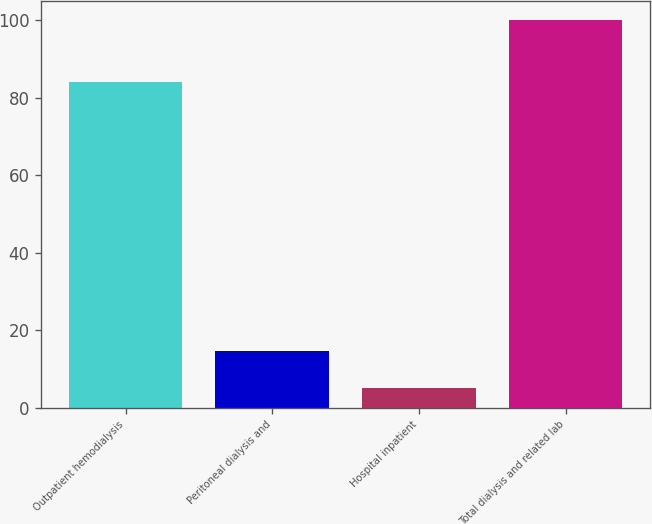<chart> <loc_0><loc_0><loc_500><loc_500><bar_chart><fcel>Outpatient hemodialysis<fcel>Peritoneal dialysis and<fcel>Hospital inpatient<fcel>Total dialysis and related lab<nl><fcel>84<fcel>14.5<fcel>5<fcel>100<nl></chart> 